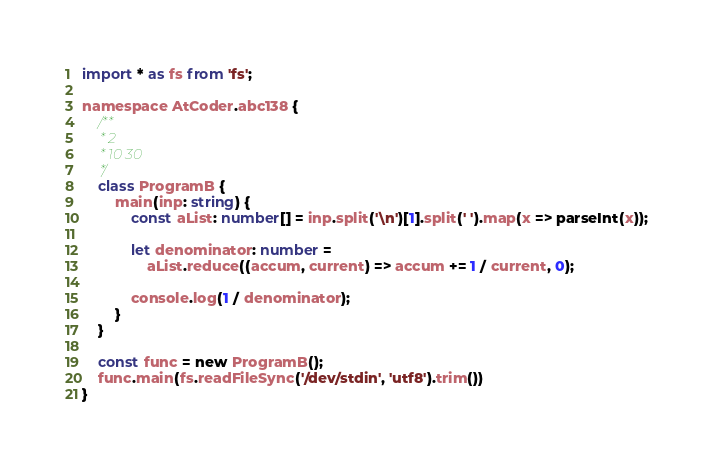<code> <loc_0><loc_0><loc_500><loc_500><_TypeScript_>import * as fs from 'fs';

namespace AtCoder.abc138 {
    /**
     * 2
     * 10 30
     */
    class ProgramB {
        main(inp: string) {
            const aList: number[] = inp.split('\n')[1].split(' ').map(x => parseInt(x));

            let denominator: number =
                aList.reduce((accum, current) => accum += 1 / current, 0);

            console.log(1 / denominator);
        }
    }

    const func = new ProgramB();
    func.main(fs.readFileSync('/dev/stdin', 'utf8').trim())
}</code> 